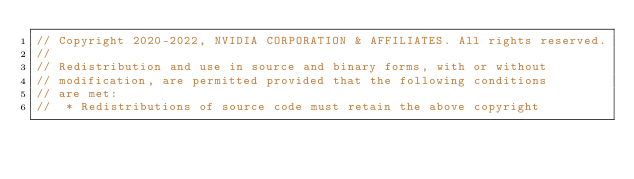<code> <loc_0><loc_0><loc_500><loc_500><_C_>// Copyright 2020-2022, NVIDIA CORPORATION & AFFILIATES. All rights reserved.
//
// Redistribution and use in source and binary forms, with or without
// modification, are permitted provided that the following conditions
// are met:
//  * Redistributions of source code must retain the above copyright</code> 